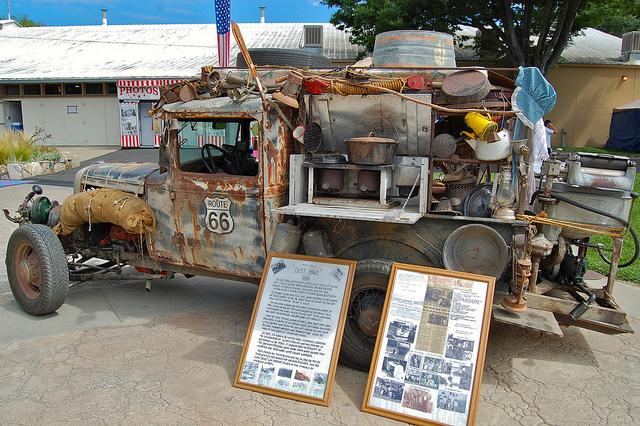What numbers appear on the side of the truck?
Write a very short answer. 66. Is the truck independent or owned by a business?
Answer briefly. Independent. Is this an exhibition?
Short answer required. Yes. Is this a new truck?
Short answer required. No. 